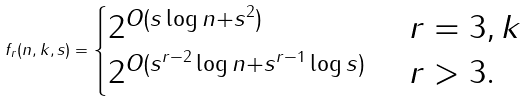Convert formula to latex. <formula><loc_0><loc_0><loc_500><loc_500>f _ { r } ( n , k , s ) = \begin{cases} 2 ^ { O ( s \log n + s ^ { 2 } ) } & \ r = 3 , k \\ 2 ^ { O ( s ^ { r - 2 } \log n + s ^ { r - 1 } \log s ) } & \ r > 3 . \end{cases}</formula> 